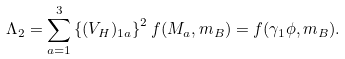Convert formula to latex. <formula><loc_0><loc_0><loc_500><loc_500>\Lambda _ { 2 } = \sum _ { a = 1 } ^ { 3 } \left \{ ( V _ { H } ) _ { 1 a } \right \} ^ { 2 } f ( M _ { a } , m _ { B } ) = f ( \gamma _ { 1 } \phi , m _ { B } ) .</formula> 